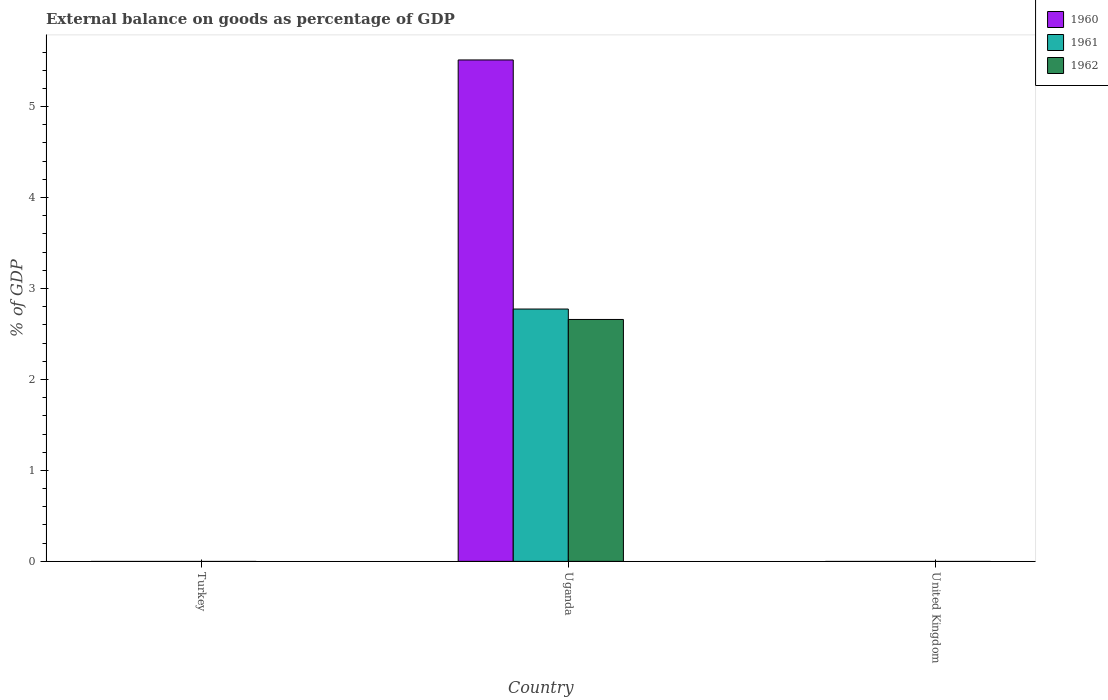Are the number of bars on each tick of the X-axis equal?
Ensure brevity in your answer.  No. How many bars are there on the 2nd tick from the left?
Offer a terse response. 3. What is the label of the 1st group of bars from the left?
Your answer should be very brief. Turkey. What is the external balance on goods as percentage of GDP in 1960 in United Kingdom?
Provide a short and direct response. 0. Across all countries, what is the maximum external balance on goods as percentage of GDP in 1961?
Offer a very short reply. 2.77. Across all countries, what is the minimum external balance on goods as percentage of GDP in 1962?
Provide a succinct answer. 0. In which country was the external balance on goods as percentage of GDP in 1962 maximum?
Give a very brief answer. Uganda. What is the total external balance on goods as percentage of GDP in 1961 in the graph?
Offer a terse response. 2.77. What is the difference between the external balance on goods as percentage of GDP in 1960 in Uganda and the external balance on goods as percentage of GDP in 1962 in Turkey?
Provide a short and direct response. 5.51. What is the average external balance on goods as percentage of GDP in 1962 per country?
Provide a short and direct response. 0.89. What is the difference between the external balance on goods as percentage of GDP of/in 1962 and external balance on goods as percentage of GDP of/in 1961 in Uganda?
Offer a very short reply. -0.11. What is the difference between the highest and the lowest external balance on goods as percentage of GDP in 1962?
Keep it short and to the point. 2.66. Is it the case that in every country, the sum of the external balance on goods as percentage of GDP in 1960 and external balance on goods as percentage of GDP in 1961 is greater than the external balance on goods as percentage of GDP in 1962?
Provide a succinct answer. No. Are the values on the major ticks of Y-axis written in scientific E-notation?
Your answer should be compact. No. Does the graph contain grids?
Your answer should be compact. No. What is the title of the graph?
Provide a succinct answer. External balance on goods as percentage of GDP. Does "2013" appear as one of the legend labels in the graph?
Your response must be concise. No. What is the label or title of the X-axis?
Provide a succinct answer. Country. What is the label or title of the Y-axis?
Your answer should be compact. % of GDP. What is the % of GDP in 1960 in Turkey?
Your answer should be compact. 0. What is the % of GDP in 1961 in Turkey?
Your answer should be compact. 0. What is the % of GDP of 1960 in Uganda?
Provide a short and direct response. 5.51. What is the % of GDP of 1961 in Uganda?
Offer a terse response. 2.77. What is the % of GDP of 1962 in Uganda?
Provide a succinct answer. 2.66. What is the % of GDP in 1962 in United Kingdom?
Keep it short and to the point. 0. Across all countries, what is the maximum % of GDP in 1960?
Your answer should be very brief. 5.51. Across all countries, what is the maximum % of GDP of 1961?
Your answer should be very brief. 2.77. Across all countries, what is the maximum % of GDP in 1962?
Make the answer very short. 2.66. Across all countries, what is the minimum % of GDP in 1960?
Keep it short and to the point. 0. Across all countries, what is the minimum % of GDP in 1961?
Keep it short and to the point. 0. What is the total % of GDP of 1960 in the graph?
Offer a terse response. 5.51. What is the total % of GDP in 1961 in the graph?
Provide a short and direct response. 2.77. What is the total % of GDP in 1962 in the graph?
Ensure brevity in your answer.  2.66. What is the average % of GDP of 1960 per country?
Keep it short and to the point. 1.84. What is the average % of GDP in 1961 per country?
Offer a very short reply. 0.92. What is the average % of GDP of 1962 per country?
Offer a terse response. 0.89. What is the difference between the % of GDP of 1960 and % of GDP of 1961 in Uganda?
Give a very brief answer. 2.74. What is the difference between the % of GDP of 1960 and % of GDP of 1962 in Uganda?
Make the answer very short. 2.85. What is the difference between the % of GDP in 1961 and % of GDP in 1962 in Uganda?
Your answer should be very brief. 0.11. What is the difference between the highest and the lowest % of GDP in 1960?
Give a very brief answer. 5.51. What is the difference between the highest and the lowest % of GDP of 1961?
Keep it short and to the point. 2.77. What is the difference between the highest and the lowest % of GDP in 1962?
Offer a terse response. 2.66. 